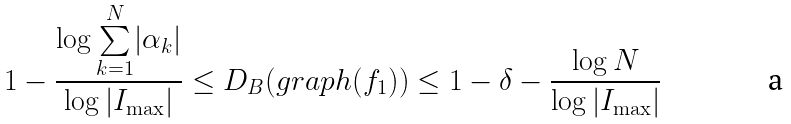<formula> <loc_0><loc_0><loc_500><loc_500>1 - \frac { \log \underset { k = 1 } { \overset { N } \sum } | \alpha _ { k } | } { \log | I _ { \max } | } \leq D _ { B } ( g r a p h ( f _ { 1 } ) ) \leq 1 - \delta - \frac { \log N } { \log | I _ { \max } | }</formula> 